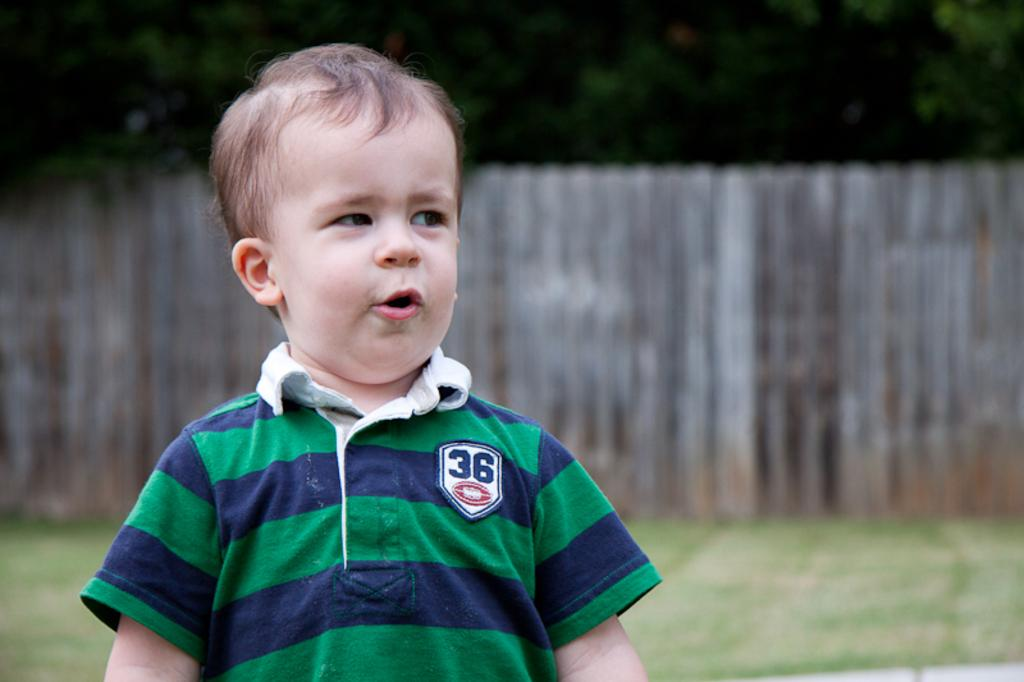Provide a one-sentence caption for the provided image. Little boy standing outside with his mouth wide open. 